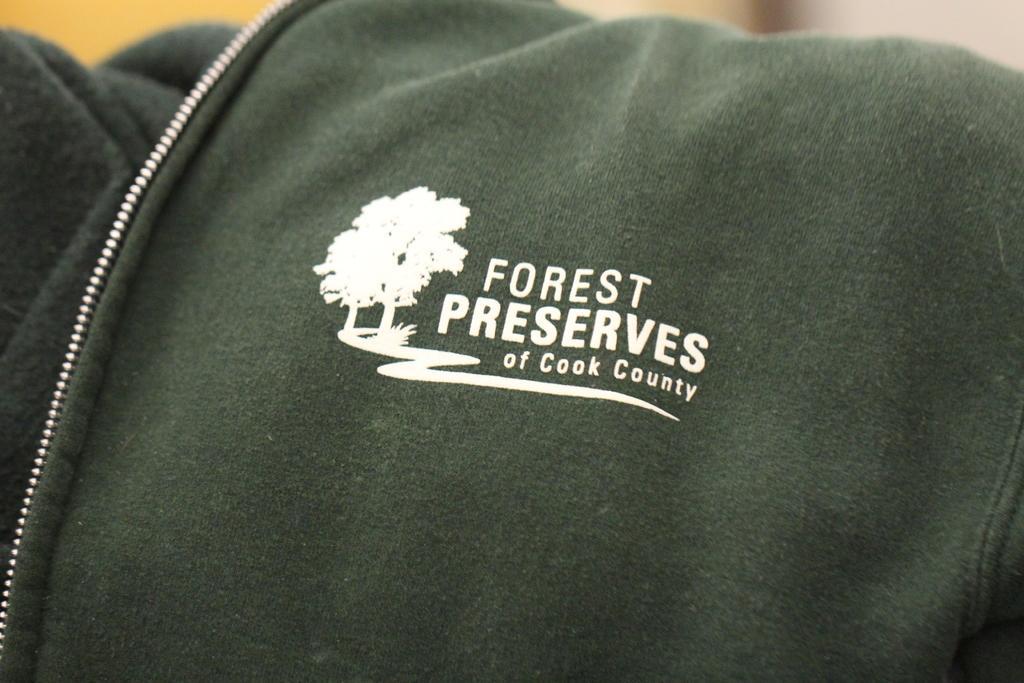Describe this image in one or two sentences. Is this picture I can see there is a coat and there is a logo on it, there are trees and something written on it. The coat has a metal zip. 